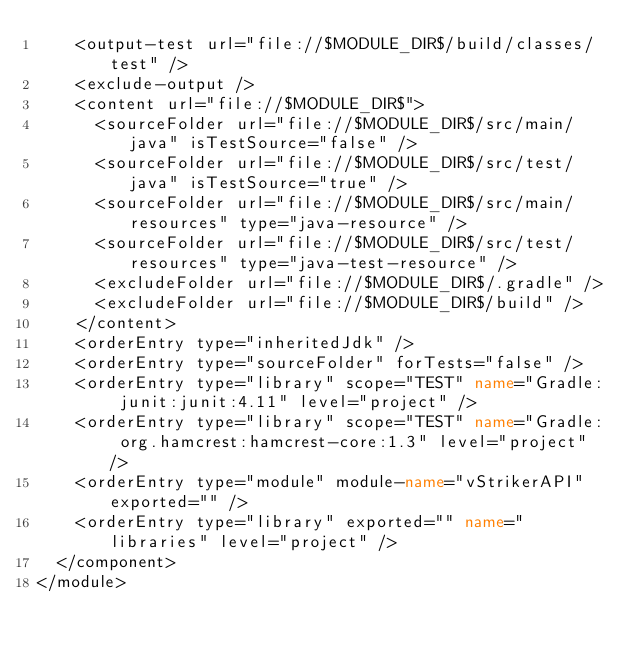<code> <loc_0><loc_0><loc_500><loc_500><_XML_>    <output-test url="file://$MODULE_DIR$/build/classes/test" />
    <exclude-output />
    <content url="file://$MODULE_DIR$">
      <sourceFolder url="file://$MODULE_DIR$/src/main/java" isTestSource="false" />
      <sourceFolder url="file://$MODULE_DIR$/src/test/java" isTestSource="true" />
      <sourceFolder url="file://$MODULE_DIR$/src/main/resources" type="java-resource" />
      <sourceFolder url="file://$MODULE_DIR$/src/test/resources" type="java-test-resource" />
      <excludeFolder url="file://$MODULE_DIR$/.gradle" />
      <excludeFolder url="file://$MODULE_DIR$/build" />
    </content>
    <orderEntry type="inheritedJdk" />
    <orderEntry type="sourceFolder" forTests="false" />
    <orderEntry type="library" scope="TEST" name="Gradle: junit:junit:4.11" level="project" />
    <orderEntry type="library" scope="TEST" name="Gradle: org.hamcrest:hamcrest-core:1.3" level="project" />
    <orderEntry type="module" module-name="vStrikerAPI" exported="" />
    <orderEntry type="library" exported="" name="libraries" level="project" />
  </component>
</module></code> 